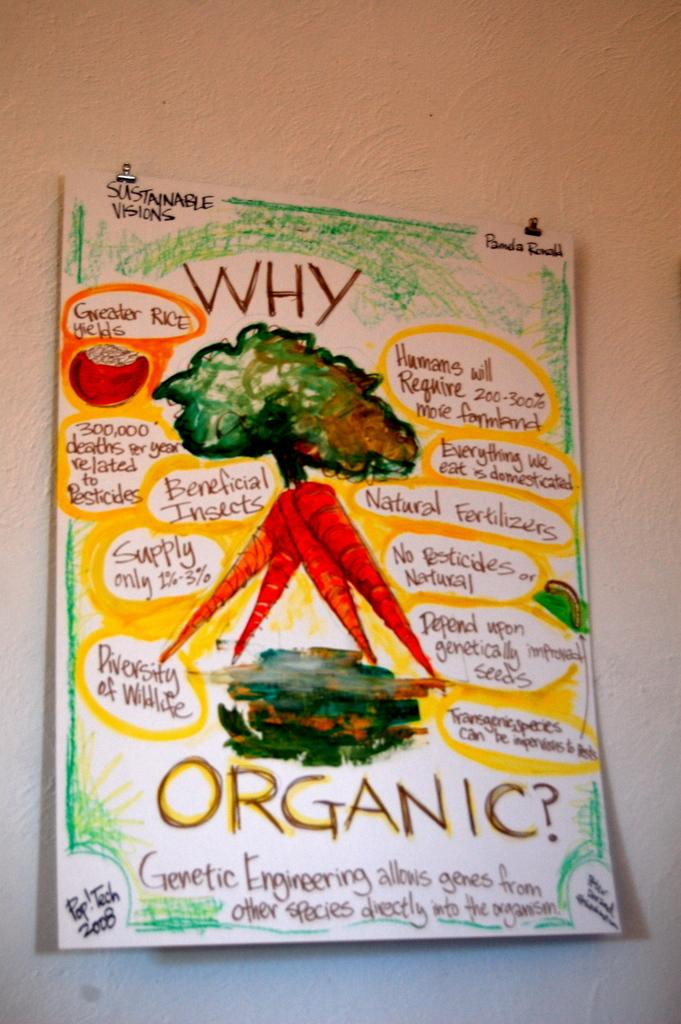What is on the wall in the image? There is a poster on the wall. What is depicted on the poster? The poster contains images of carrots. Is there any text on the poster? Yes, there is text written on the poster. How many trucks are visible on the quilt in the image? There is no quilt or truck present in the image; it features a poster with images of carrots and text. 